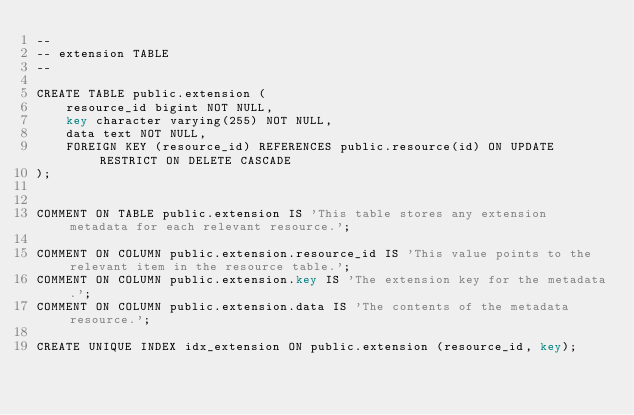Convert code to text. <code><loc_0><loc_0><loc_500><loc_500><_SQL_>--
-- extension TABLE
--

CREATE TABLE public.extension (
    resource_id bigint NOT NULL,
    key character varying(255) NOT NULL,
    data text NOT NULL,
    FOREIGN KEY (resource_id) REFERENCES public.resource(id) ON UPDATE RESTRICT ON DELETE CASCADE
);


COMMENT ON TABLE public.extension IS 'This table stores any extension metadata for each relevant resource.';

COMMENT ON COLUMN public.extension.resource_id IS 'This value points to the relevant item in the resource table.';
COMMENT ON COLUMN public.extension.key IS 'The extension key for the metadata.';
COMMENT ON COLUMN public.extension.data IS 'The contents of the metadata resource.';

CREATE UNIQUE INDEX idx_extension ON public.extension (resource_id, key);


</code> 